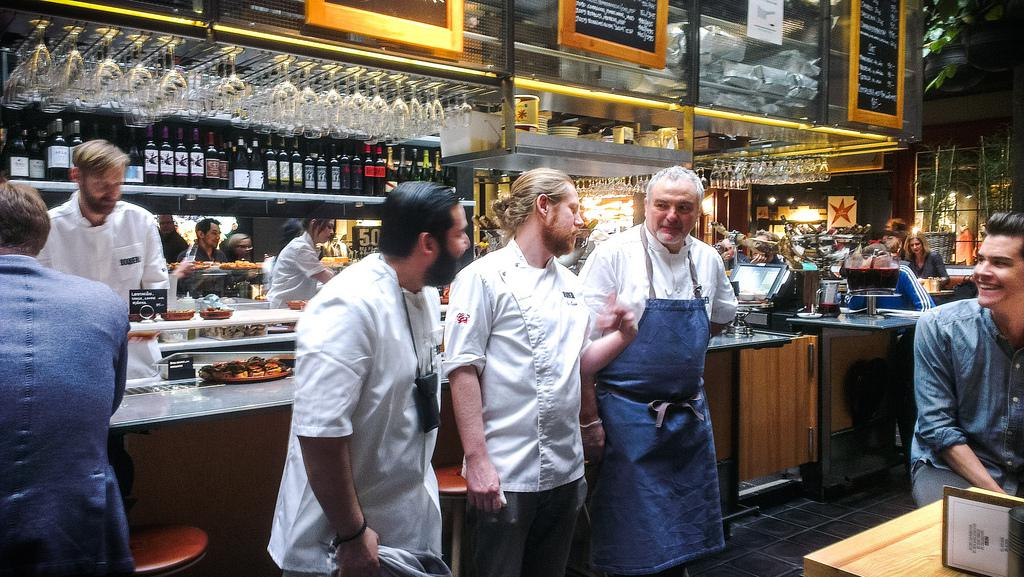Question: how many women are this picture?
Choices:
A. Seven.
B. None.
C. Six.
D. One.
Answer with the letter. Answer: B Question: who has a pony tail in this picture?
Choices:
A. The girl on the right.
B. The boy on the left.
C. The girl laying on the ground.
D. The man in the middle.
Answer with the letter. Answer: D Question: what geometric shape is on the right of this picture?
Choices:
A. A Trapezoid.
B. A Sphere.
C. A Rectangular Prism.
D. A star.
Answer with the letter. Answer: D Question: where are the conversing restaurant employees standing?
Choices:
A. In the kitchen.
B. Outside.
C. In the back.
D. In front of the bar.
Answer with the letter. Answer: D Question: what color apron does the man wear?
Choices:
A. Maroon.
B. Green.
C. Orange.
D. Blue.
Answer with the letter. Answer: D Question: what does the man behind the bar have on his face?
Choices:
A. A pimple.
B. A beard.
C. A cut.
D. A bandage.
Answer with the letter. Answer: B Question: what has art that is a red star with white background?
Choices:
A. Wall in kitchen.
B. DIshes.
C. Wall in dining area.
D. Magazine.
Answer with the letter. Answer: C Question: where does man sit?
Choices:
A. On a stool.
B. On the floor.
C. On a chair.
D. At a table.
Answer with the letter. Answer: A Question: where are the wine glasses?
Choices:
A. In the china cabinet.
B. Above the bar.
C. On the table.
D. On the counter.
Answer with the letter. Answer: B Question: who has his back to us?
Choices:
A. A woman in a red dress.
B. A man in a blue suit.
C. A girl in a pink shirt and blue jeans.
D. Two teenagers who appear to be hugging.
Answer with the letter. Answer: B Question: what is the man in the front of the picture doing?
Choices:
A. Eating.
B. Smiling.
C. Drinking.
D. Smoking.
Answer with the letter. Answer: B Question: how does the restaurant/bar seem to be?
Choices:
A. Sparse.
B. Empty.
C. Quite busy.
D. A little full.
Answer with the letter. Answer: C Question: who is wearing a watch?
Choices:
A. The old man with gray hair.
B. The employee closest to the camera.
C. The boy in the red race car shirt.
D. The waitress.
Answer with the letter. Answer: B Question: how many menu boards are visible above the bar?
Choices:
A. Two.
B. Three.
C. Four.
D. Five.
Answer with the letter. Answer: B Question: where are menus posted?
Choices:
A. Overhead.
B. On the wall.
C. Behind the register.
D. On flyers.
Answer with the letter. Answer: A 